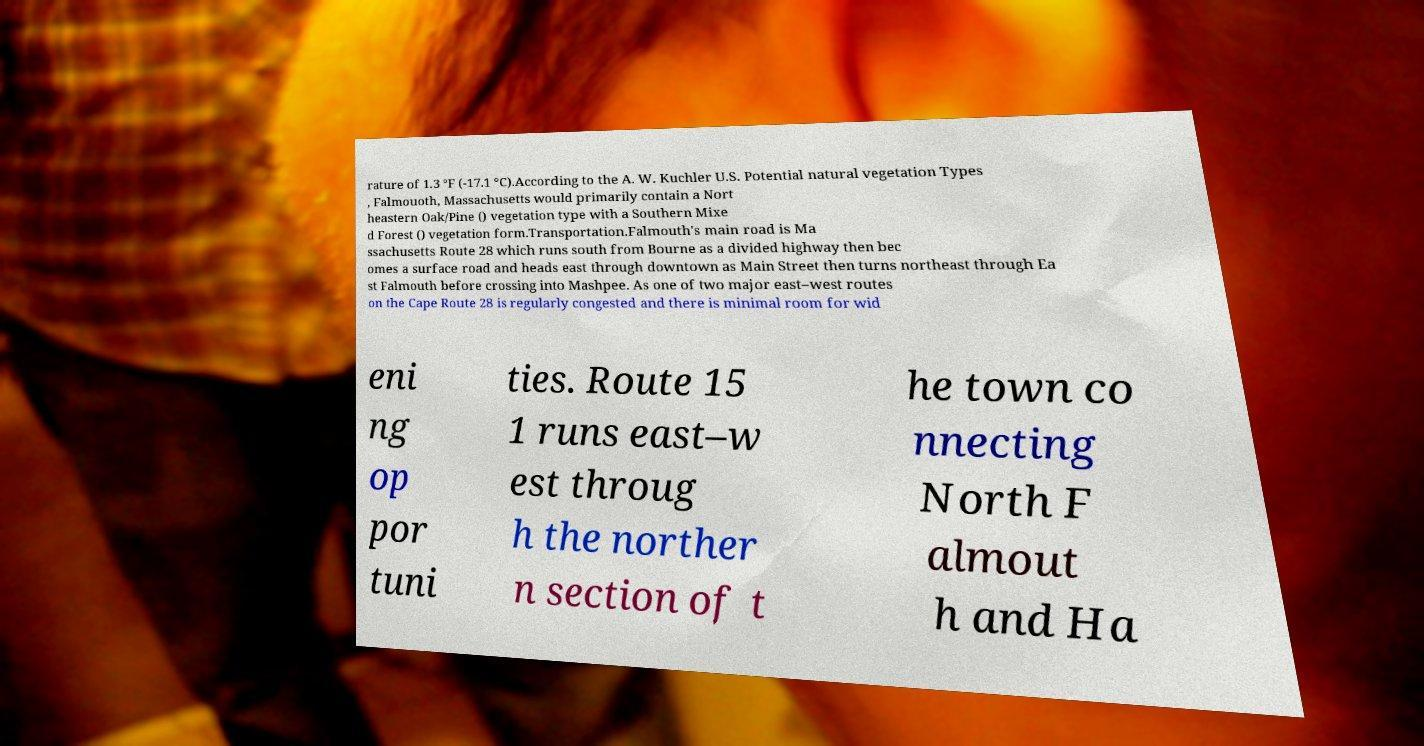Could you extract and type out the text from this image? rature of 1.3 °F (-17.1 °C).According to the A. W. Kuchler U.S. Potential natural vegetation Types , Falmouoth, Massachusetts would primarily contain a Nort heastern Oak/Pine () vegetation type with a Southern Mixe d Forest () vegetation form.Transportation.Falmouth's main road is Ma ssachusetts Route 28 which runs south from Bourne as a divided highway then bec omes a surface road and heads east through downtown as Main Street then turns northeast through Ea st Falmouth before crossing into Mashpee. As one of two major east–west routes on the Cape Route 28 is regularly congested and there is minimal room for wid eni ng op por tuni ties. Route 15 1 runs east–w est throug h the norther n section of t he town co nnecting North F almout h and Ha 